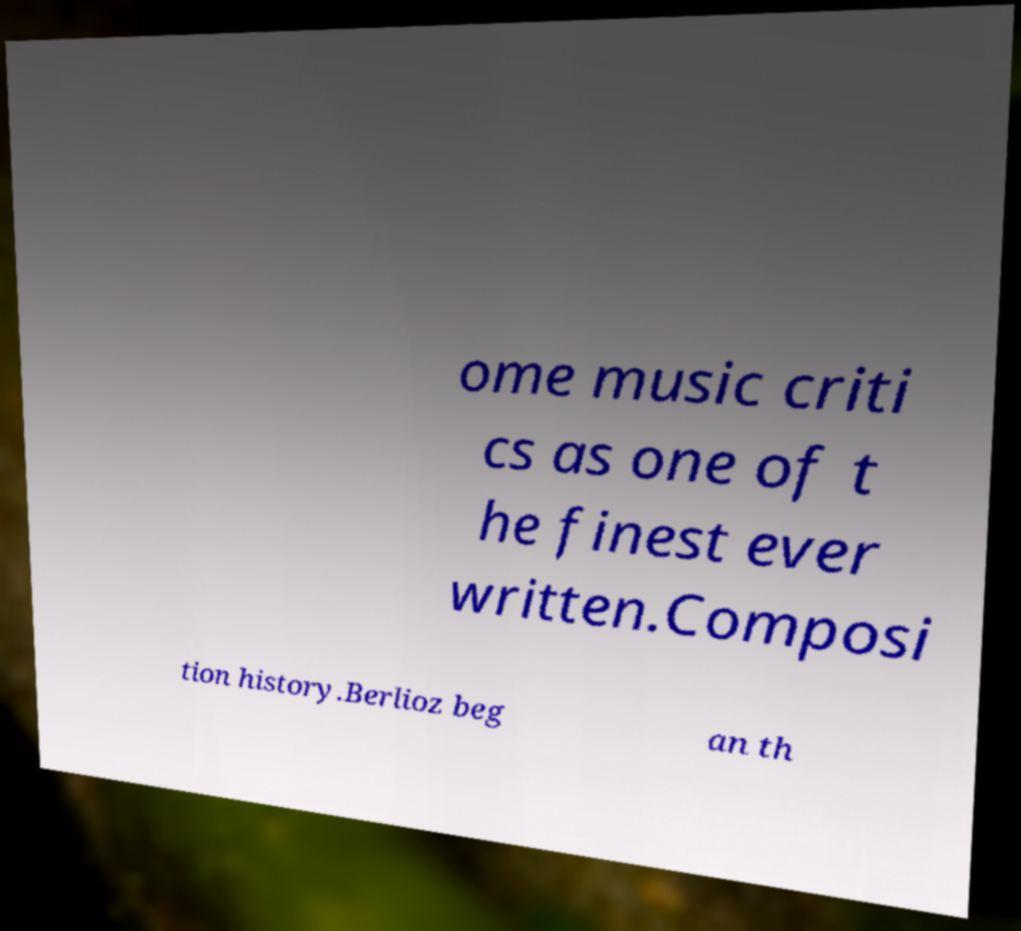Could you extract and type out the text from this image? ome music criti cs as one of t he finest ever written.Composi tion history.Berlioz beg an th 